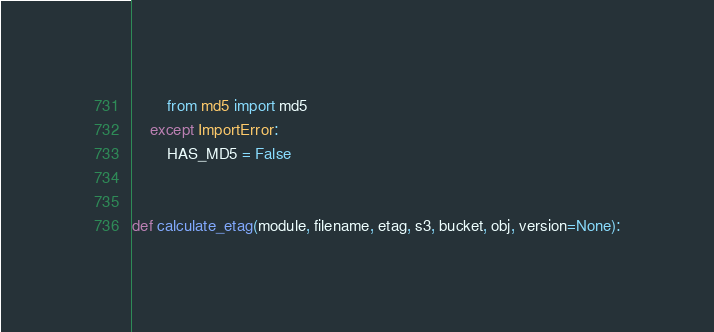<code> <loc_0><loc_0><loc_500><loc_500><_Python_>        from md5 import md5
    except ImportError:
        HAS_MD5 = False


def calculate_etag(module, filename, etag, s3, bucket, obj, version=None):</code> 